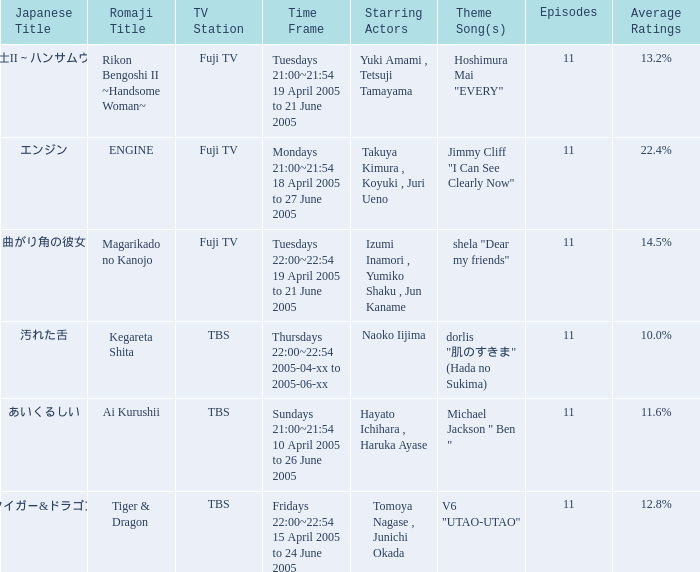What is the Japanese title with an average rating of 11.6%? あいくるしい. 